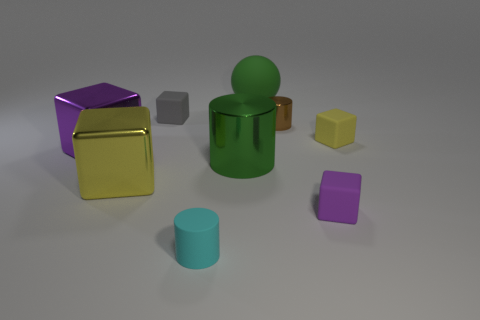What materials seem to be represented by the different objects in this image? The objects in the image appear to simulate various materials: the shiny gold and purple cubes suggest a metallic texture, the cyan cylinder looks like it could be ceramic due to its matte surface, while the green figure and gray cube give off a plastic-like appearance. 